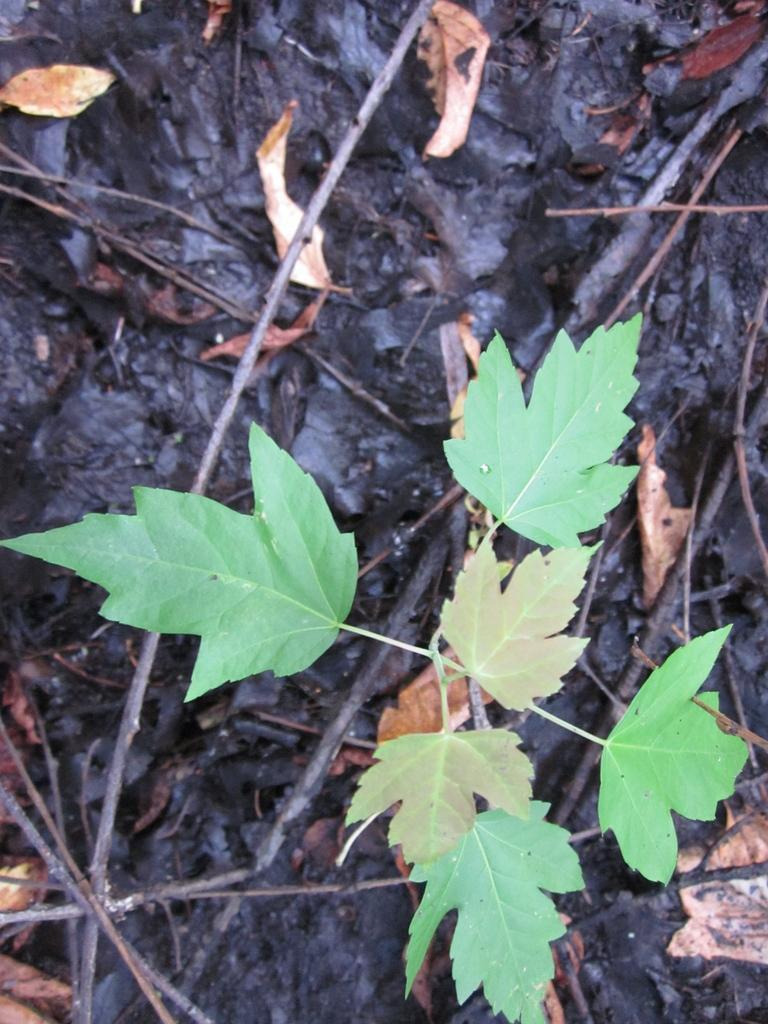What type of plant parts can be seen in the image? There are leaves and stems in the image. Can you describe the appearance of the leaves? The leaves in the image have a specific shape and color, but the exact details are not provided. What is the relationship between the leaves and stems? The leaves are connected to the stems in the image. How many friends does the toe have in the image? There are no friends or toes present in the image; it only features leaves and stems. 